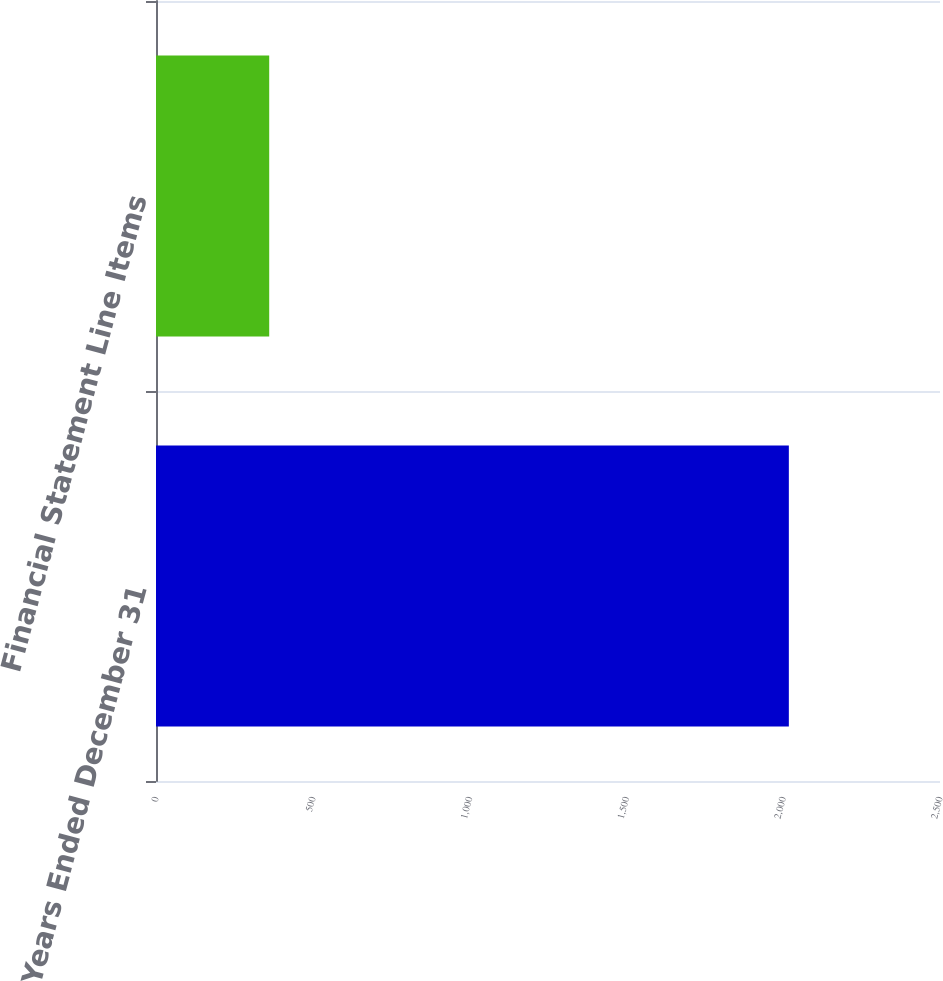<chart> <loc_0><loc_0><loc_500><loc_500><bar_chart><fcel>Years Ended December 31<fcel>Financial Statement Line Items<nl><fcel>2018<fcel>361<nl></chart> 